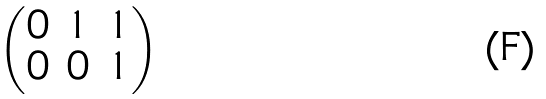<formula> <loc_0><loc_0><loc_500><loc_500>\begin{pmatrix} 0 & 1 & 1 \\ 0 & 0 & 1 \end{pmatrix}</formula> 